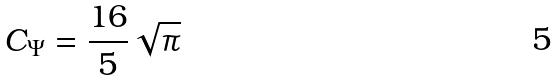<formula> <loc_0><loc_0><loc_500><loc_500>C _ { \Psi } = \frac { 1 6 } { 5 } \sqrt { \pi }</formula> 